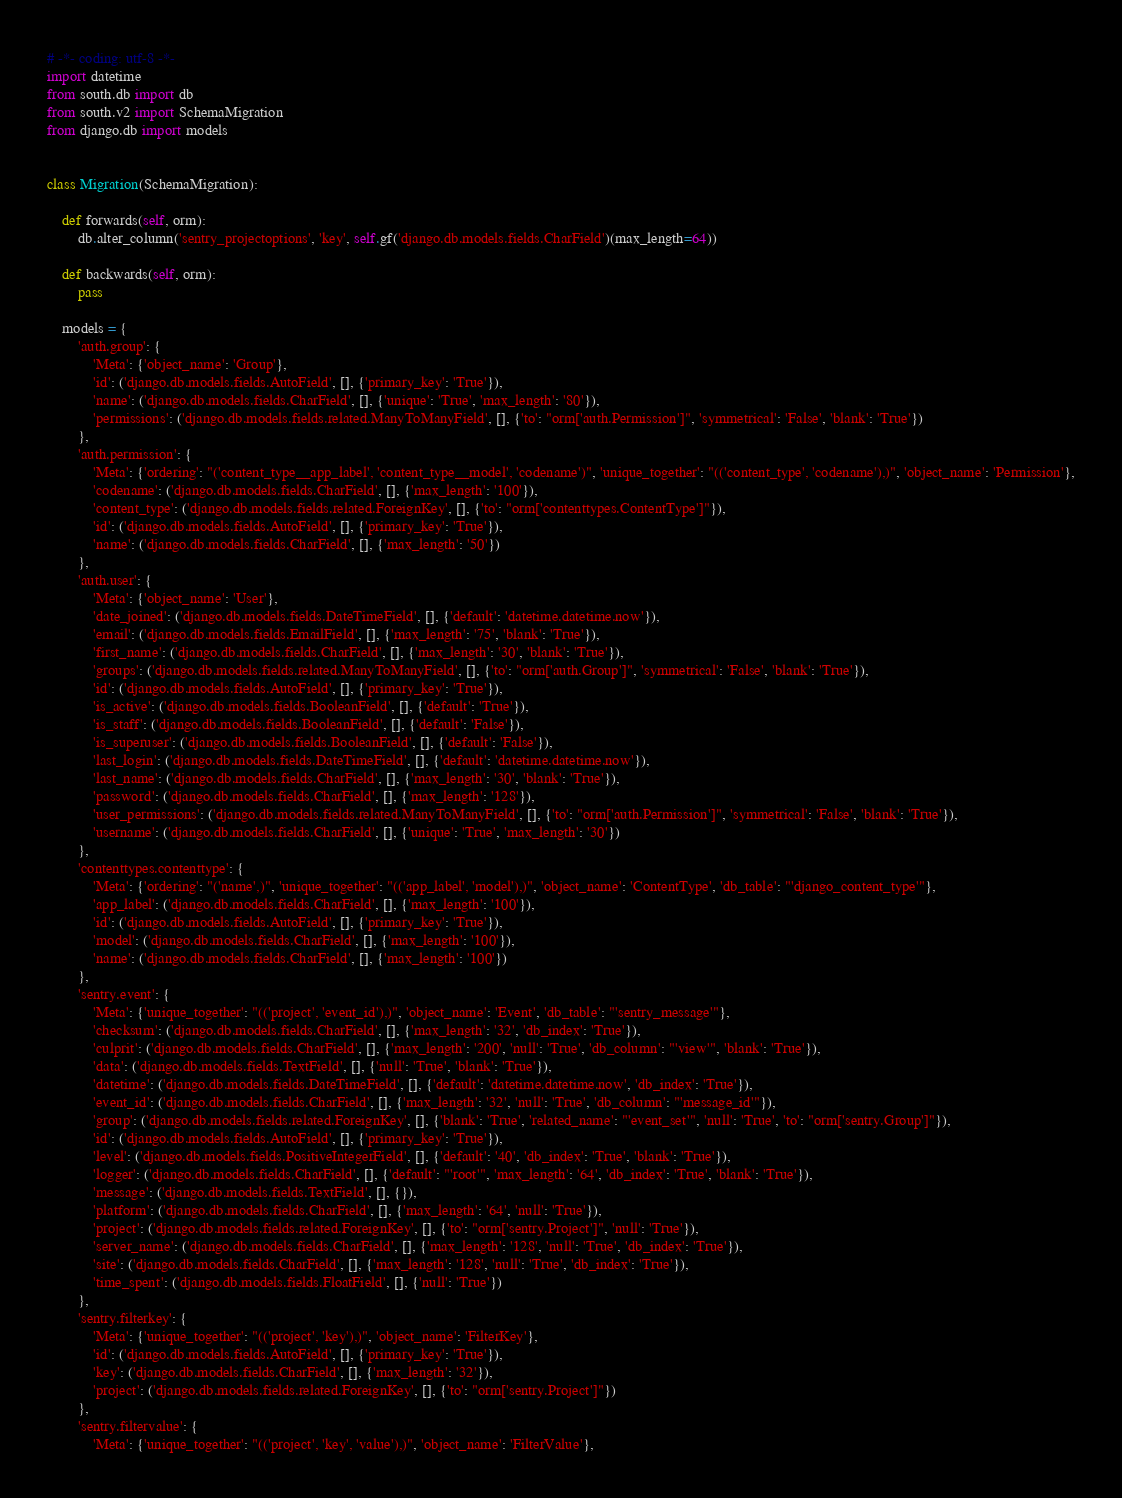Convert code to text. <code><loc_0><loc_0><loc_500><loc_500><_Python_># -*- coding: utf-8 -*-
import datetime
from south.db import db
from south.v2 import SchemaMigration
from django.db import models


class Migration(SchemaMigration):

    def forwards(self, orm):
        db.alter_column('sentry_projectoptions', 'key', self.gf('django.db.models.fields.CharField')(max_length=64))

    def backwards(self, orm):
        pass

    models = {
        'auth.group': {
            'Meta': {'object_name': 'Group'},
            'id': ('django.db.models.fields.AutoField', [], {'primary_key': 'True'}),
            'name': ('django.db.models.fields.CharField', [], {'unique': 'True', 'max_length': '80'}),
            'permissions': ('django.db.models.fields.related.ManyToManyField', [], {'to': "orm['auth.Permission']", 'symmetrical': 'False', 'blank': 'True'})
        },
        'auth.permission': {
            'Meta': {'ordering': "('content_type__app_label', 'content_type__model', 'codename')", 'unique_together': "(('content_type', 'codename'),)", 'object_name': 'Permission'},
            'codename': ('django.db.models.fields.CharField', [], {'max_length': '100'}),
            'content_type': ('django.db.models.fields.related.ForeignKey', [], {'to': "orm['contenttypes.ContentType']"}),
            'id': ('django.db.models.fields.AutoField', [], {'primary_key': 'True'}),
            'name': ('django.db.models.fields.CharField', [], {'max_length': '50'})
        },
        'auth.user': {
            'Meta': {'object_name': 'User'},
            'date_joined': ('django.db.models.fields.DateTimeField', [], {'default': 'datetime.datetime.now'}),
            'email': ('django.db.models.fields.EmailField', [], {'max_length': '75', 'blank': 'True'}),
            'first_name': ('django.db.models.fields.CharField', [], {'max_length': '30', 'blank': 'True'}),
            'groups': ('django.db.models.fields.related.ManyToManyField', [], {'to': "orm['auth.Group']", 'symmetrical': 'False', 'blank': 'True'}),
            'id': ('django.db.models.fields.AutoField', [], {'primary_key': 'True'}),
            'is_active': ('django.db.models.fields.BooleanField', [], {'default': 'True'}),
            'is_staff': ('django.db.models.fields.BooleanField', [], {'default': 'False'}),
            'is_superuser': ('django.db.models.fields.BooleanField', [], {'default': 'False'}),
            'last_login': ('django.db.models.fields.DateTimeField', [], {'default': 'datetime.datetime.now'}),
            'last_name': ('django.db.models.fields.CharField', [], {'max_length': '30', 'blank': 'True'}),
            'password': ('django.db.models.fields.CharField', [], {'max_length': '128'}),
            'user_permissions': ('django.db.models.fields.related.ManyToManyField', [], {'to': "orm['auth.Permission']", 'symmetrical': 'False', 'blank': 'True'}),
            'username': ('django.db.models.fields.CharField', [], {'unique': 'True', 'max_length': '30'})
        },
        'contenttypes.contenttype': {
            'Meta': {'ordering': "('name',)", 'unique_together': "(('app_label', 'model'),)", 'object_name': 'ContentType', 'db_table': "'django_content_type'"},
            'app_label': ('django.db.models.fields.CharField', [], {'max_length': '100'}),
            'id': ('django.db.models.fields.AutoField', [], {'primary_key': 'True'}),
            'model': ('django.db.models.fields.CharField', [], {'max_length': '100'}),
            'name': ('django.db.models.fields.CharField', [], {'max_length': '100'})
        },
        'sentry.event': {
            'Meta': {'unique_together': "(('project', 'event_id'),)", 'object_name': 'Event', 'db_table': "'sentry_message'"},
            'checksum': ('django.db.models.fields.CharField', [], {'max_length': '32', 'db_index': 'True'}),
            'culprit': ('django.db.models.fields.CharField', [], {'max_length': '200', 'null': 'True', 'db_column': "'view'", 'blank': 'True'}),
            'data': ('django.db.models.fields.TextField', [], {'null': 'True', 'blank': 'True'}),
            'datetime': ('django.db.models.fields.DateTimeField', [], {'default': 'datetime.datetime.now', 'db_index': 'True'}),
            'event_id': ('django.db.models.fields.CharField', [], {'max_length': '32', 'null': 'True', 'db_column': "'message_id'"}),
            'group': ('django.db.models.fields.related.ForeignKey', [], {'blank': 'True', 'related_name': "'event_set'", 'null': 'True', 'to': "orm['sentry.Group']"}),
            'id': ('django.db.models.fields.AutoField', [], {'primary_key': 'True'}),
            'level': ('django.db.models.fields.PositiveIntegerField', [], {'default': '40', 'db_index': 'True', 'blank': 'True'}),
            'logger': ('django.db.models.fields.CharField', [], {'default': "'root'", 'max_length': '64', 'db_index': 'True', 'blank': 'True'}),
            'message': ('django.db.models.fields.TextField', [], {}),
            'platform': ('django.db.models.fields.CharField', [], {'max_length': '64', 'null': 'True'}),
            'project': ('django.db.models.fields.related.ForeignKey', [], {'to': "orm['sentry.Project']", 'null': 'True'}),
            'server_name': ('django.db.models.fields.CharField', [], {'max_length': '128', 'null': 'True', 'db_index': 'True'}),
            'site': ('django.db.models.fields.CharField', [], {'max_length': '128', 'null': 'True', 'db_index': 'True'}),
            'time_spent': ('django.db.models.fields.FloatField', [], {'null': 'True'})
        },
        'sentry.filterkey': {
            'Meta': {'unique_together': "(('project', 'key'),)", 'object_name': 'FilterKey'},
            'id': ('django.db.models.fields.AutoField', [], {'primary_key': 'True'}),
            'key': ('django.db.models.fields.CharField', [], {'max_length': '32'}),
            'project': ('django.db.models.fields.related.ForeignKey', [], {'to': "orm['sentry.Project']"})
        },
        'sentry.filtervalue': {
            'Meta': {'unique_together': "(('project', 'key', 'value'),)", 'object_name': 'FilterValue'},</code> 